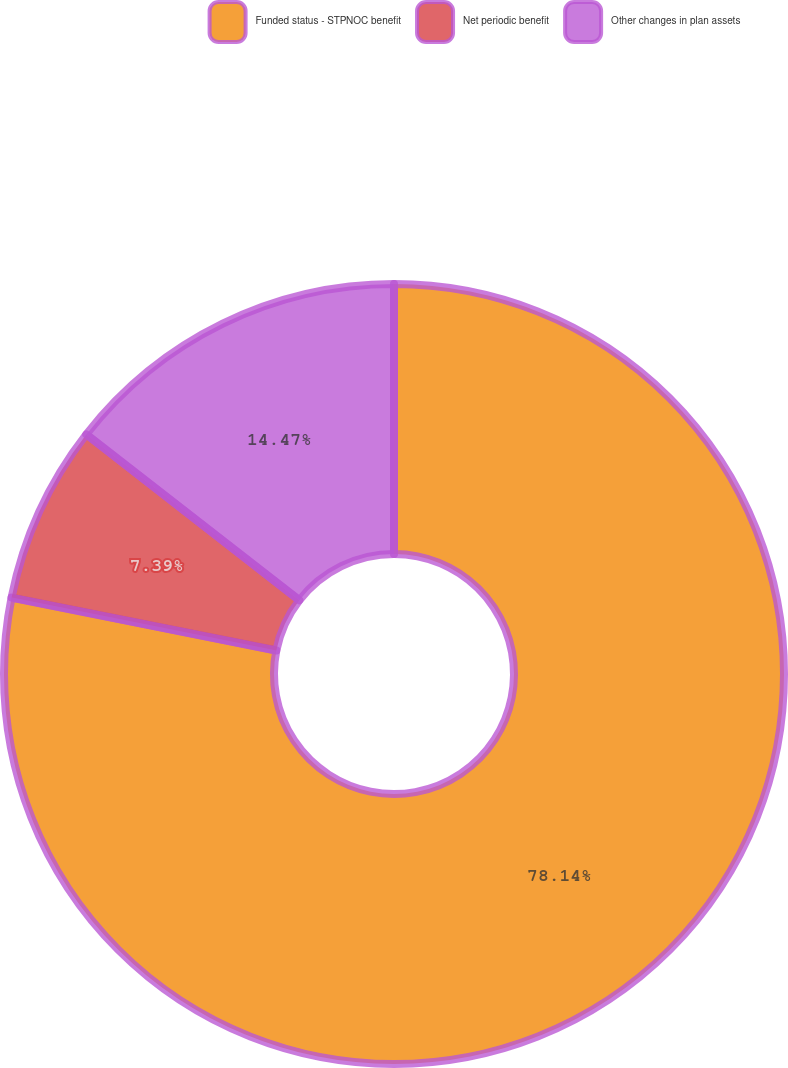Convert chart. <chart><loc_0><loc_0><loc_500><loc_500><pie_chart><fcel>Funded status - STPNOC benefit<fcel>Net periodic benefit<fcel>Other changes in plan assets<nl><fcel>78.14%<fcel>7.39%<fcel>14.47%<nl></chart> 